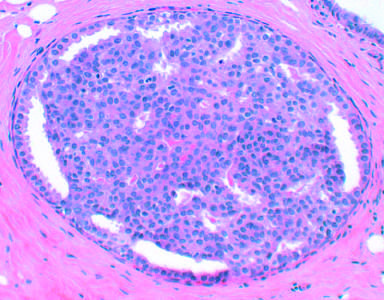what is characterized by increased numbers of epithelial cells, as in this example of epithelial hyperplasia?
Answer the question using a single word or phrase. Proliferative breast disease 